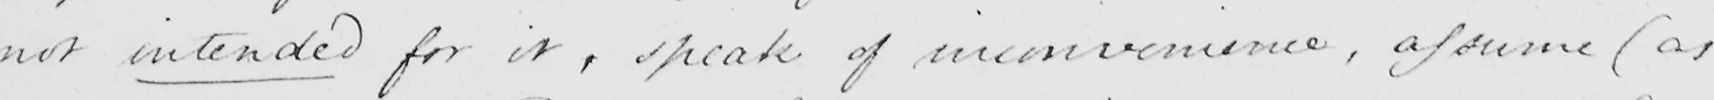Please transcribe the handwritten text in this image. not intended for it , speak of inconvenience , assume  ( as 